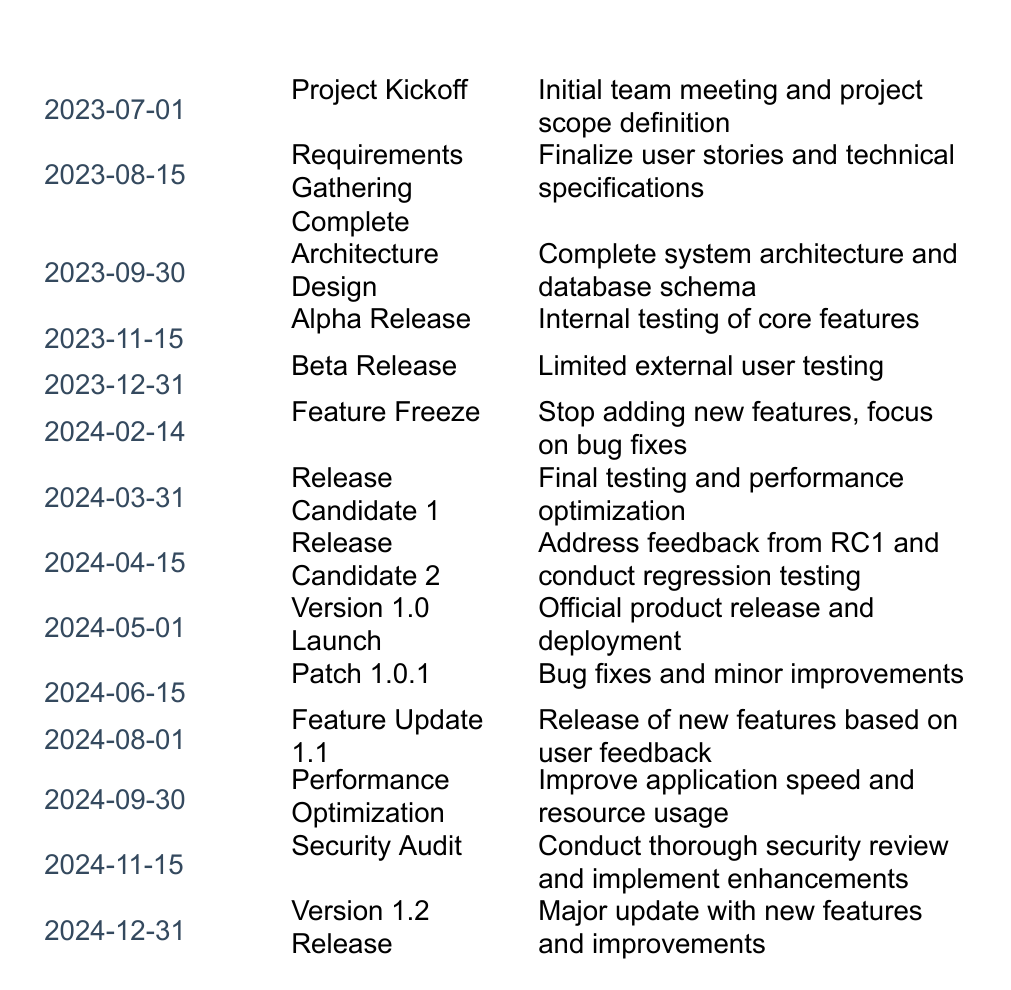What is the date for the Alpha Release? The table lists milestones along with their respective dates. By scanning the "Milestone" column, the Alpha Release is found at the entry with the date 2023-11-15.
Answer: 2023-11-15 How many total milestones are planned before the Version 1.0 Launch? I can count the milestones up to the Version 1.0 Launch, which occurs on 2024-05-01. There are 7 milestones listed before this date (from Project Kickoff to Release Candidate 2).
Answer: 7 What is the description of the Release Candidate 2 milestone? The description for Release Candidate 2 can be found by locating its date (2024-04-15) in the table. The corresponding description is "Address feedback from RC1 and conduct regression testing."
Answer: Address feedback from RC1 and conduct regression testing Is there a milestone for a security audit before the Version 1.2 Release? The table shows that there is a milestone tagged as "Security Audit" on 2024-11-15, which is before the Version 1.2 Release on 2024-12-31. Therefore, the answer is yes.
Answer: Yes What is the time span in months between the Feature Freeze and the Version 1.2 Release? The Feature Freeze occurs on 2024-02-14 and the Version 1.2 Release occurs on 2024-12-31. First, count the number of months between these dates: from February to December is 10 months (not counting February). Therefore, the time span is 10 months.
Answer: 10 months Which milestone is followed by a version number release? The Version 1.0 Launch on 2024-05-01 is directly followed by Patch 1.0.1 on 2024-06-15. Thus, the milestone right before a version number release is "Patch 1.0.1."
Answer: Patch 1.0.1 How many milestones are set to focus on bug fixes? There are two milestones specifically dedicated to bug fixes: "Feature Freeze" (2024-02-14) which is about stopping new features and focusing on bugs, and "Patch 1.0.1" (2024-06-15) which explicitly mentions bug fixes. So, there are a total of two such milestones.
Answer: 2 What is the second milestone listed in the timeline? The second milestone in the timeline, directly following the Project Kickoff, is "Requirements Gathering Complete" on 2023-08-15. This can be found by simply counting the entries in the table.
Answer: Requirements Gathering Complete 